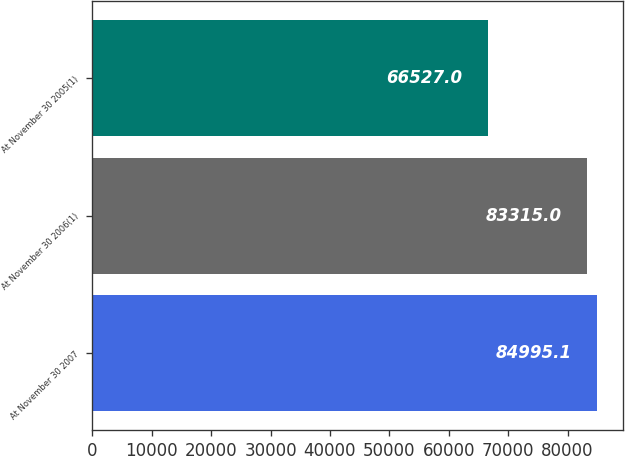<chart> <loc_0><loc_0><loc_500><loc_500><bar_chart><fcel>At November 30 2007<fcel>At November 30 2006(1)<fcel>At November 30 2005(1)<nl><fcel>84995.1<fcel>83315<fcel>66527<nl></chart> 